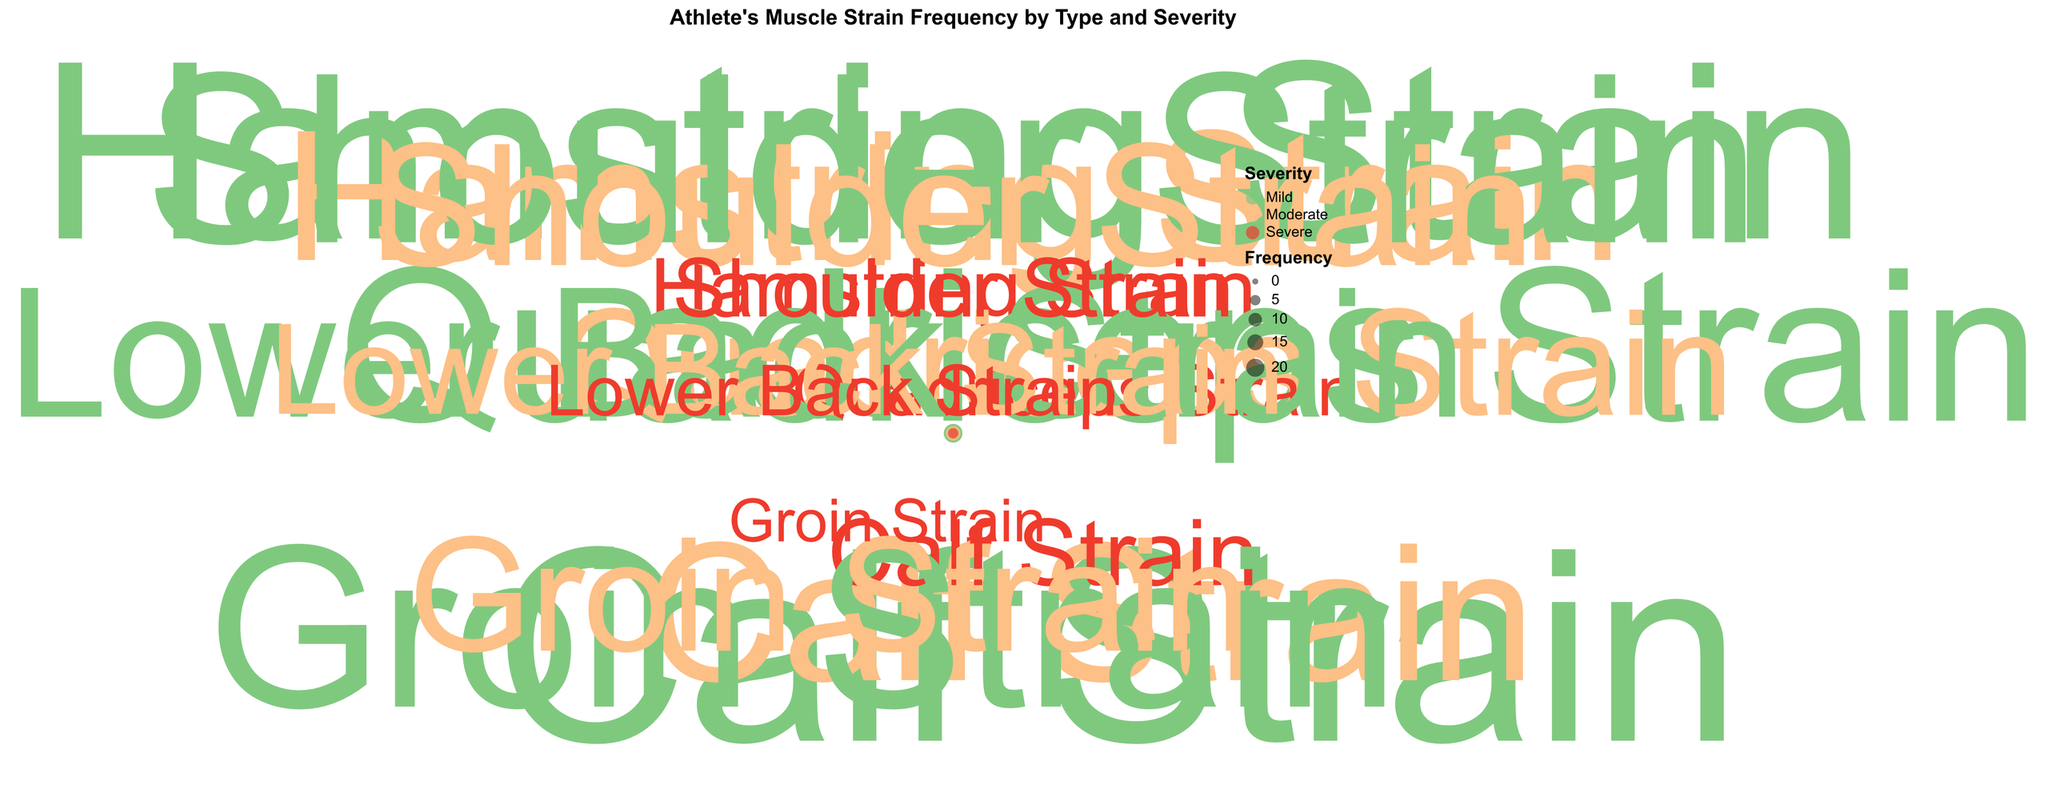What is the title of the chart? To find the title, look at the top of the chart where the heading text is usually placed.
Answer: Athlete's Muscle Strain Frequency by Type and Severity How many muscle strain types are shown in the chart? By counting the different labels on the theta axis representing muscle types, we can see the number of unique muscle strain types.
Answer: 6 Which muscle strain type has the highest frequency for mild severity? For mild severity, look for the largest radius in the chart and find the corresponding type.
Answer: Calf Strain What is the average frequency of severe strains across all muscle types? Calculate the sum of the frequencies of severe strains and divide by the number of muscle types. (5 + 4 + 6 + 3 + 4 + 5) / 6 = 27 / 6 = 4.5
Answer: 4.5 Compare the total frequency of moderate severity strains between Shoulder Strain and Lower Back Strain. Which one is higher? Refer to the frequencies of moderate severity for both types and compare them. Shoulder Strain: 13, Lower Back Strain: 9. Shoulder Strain is higher.
Answer: Shoulder Strain Which severity level has the highest frequency for Quadriceps Strain? This can be determined by comparing the range of circles for Quadriceps Strain across all severity levels. Mild (17), Moderate (11), Severe (4); thus, Mild has the highest.
Answer: Mild What is the total frequency of strains for Hamstring Strain across all severities? Add up the frequencies of Hamstring Strain across all severities: 20 (Mild) + 14 (Moderate) + 5 (Severe) = 39.
Answer: 39 Which severity level is represented by the color with the highest total frequency? Identify the severity with the most data points across all muscle strain types and compare their total frequencies. Mild strains have the highest frequency, indicated by light green.
Answer: Mild What's the least frequent muscle strain type for moderate severity? Look at the points colored for moderate severity and find the one with the smallest radius or size. Lower Back Strain has the smallest frequency for moderate severity.
Answer: Lower Back Strain 